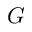Convert formula to latex. <formula><loc_0><loc_0><loc_500><loc_500>G</formula> 